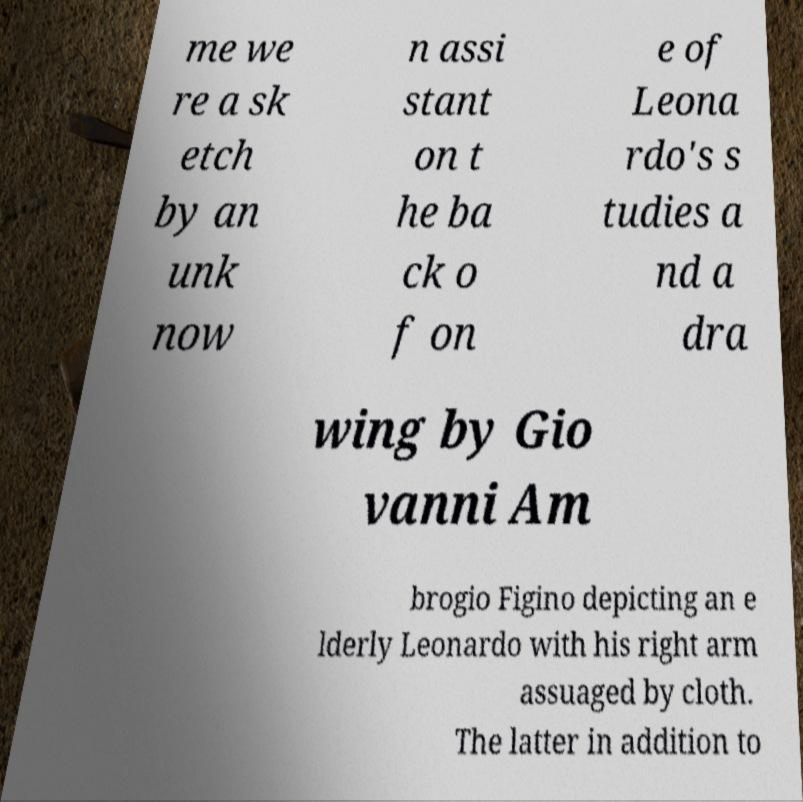Could you extract and type out the text from this image? me we re a sk etch by an unk now n assi stant on t he ba ck o f on e of Leona rdo's s tudies a nd a dra wing by Gio vanni Am brogio Figino depicting an e lderly Leonardo with his right arm assuaged by cloth. The latter in addition to 